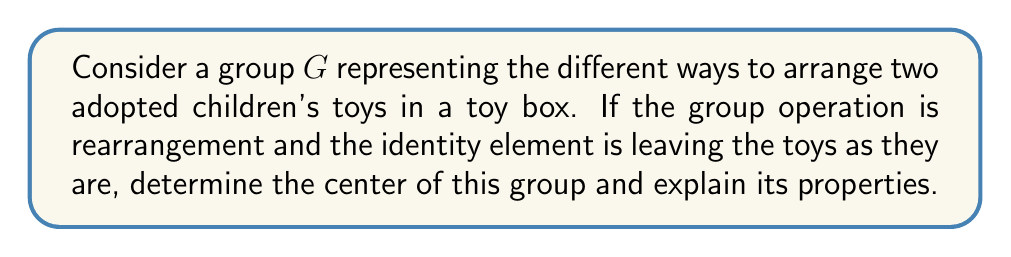Give your solution to this math problem. Let's approach this step-by-step:

1) First, let's identify the elements of the group $G$. There are two possible arrangements:
   - Identity (I): Leave the toys as they are
   - Swap (S): Swap the positions of the two toys

   So, $G = \{I, S\}$

2) The center of a group $Z(G)$ is defined as the set of all elements that commute with every element in the group. Mathematically:

   $$Z(G) = \{a \in G : ax = xa \text{ for all } x \in G\}$$

3) Let's check each element:

   For I:
   - $I \cdot I = I \cdot I = I$
   - $I \cdot S = S \cdot I = S$

   For S:
   - $S \cdot I = I \cdot S = S$
   - $S \cdot S = S \cdot S = I$

4) We can see that $I$ commutes with both $I$ and $S$, so $I$ is in the center.

5) $S$ also commutes with both $I$ and $S$, so $S$ is also in the center.

6) Therefore, the center of the group is $Z(G) = \{I, S\} = G$

Properties of the center:

1) In this case, the center is equal to the entire group. This means that $G$ is abelian (commutative).

2) The center is always a normal subgroup of $G$. Here, it's the entire group, which is always normal.

3) The quotient group $G/Z(G)$ is trivial (has only one element) because $Z(G) = G$.

4) The center is always closed under the group operation and contains the identity element.

This example illustrates how even simple, everyday scenarios like arranging toys can be represented by group structures, potentially making abstract concepts more relatable to a parent.
Answer: The center of the group $G$ is $Z(G) = \{I, S\} = G$. The group is abelian, and its center is equal to the entire group. 